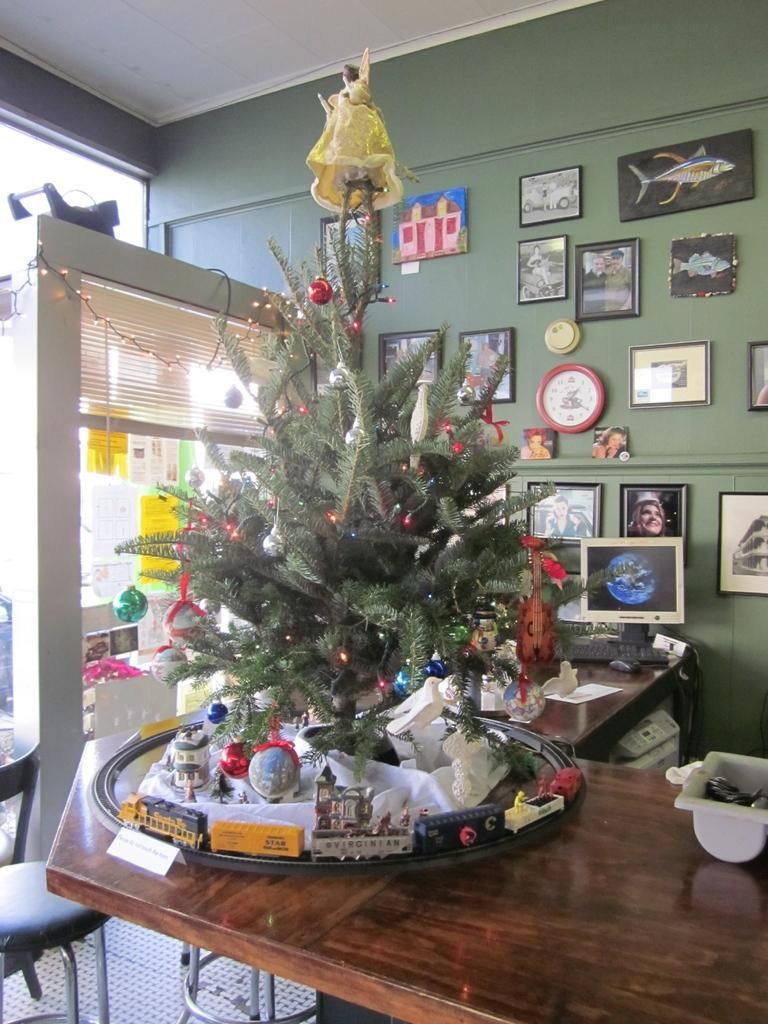What is the main object on the table in the image? There is a Christmas tree on the table in the image. What can be seen behind the Christmas tree? There is a telephone behind the Christmas tree. What type of decorations are on the wall? There are photo frames on the wall. What time-telling device is present in the image? There is a wall clock on the wall. What type of cheese is being used to decorate the Christmas tree in the image? There is no cheese present in the image, and the Christmas tree is not decorated with any food items. 